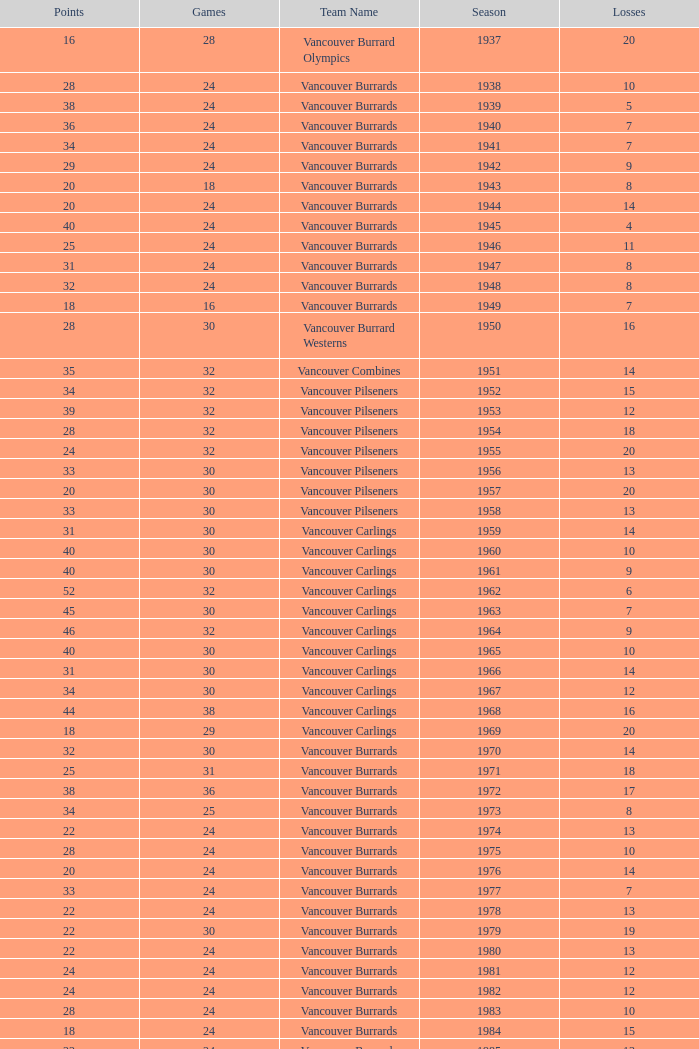What's the sum of points for the 1963 season when there are more than 30 games? None. 